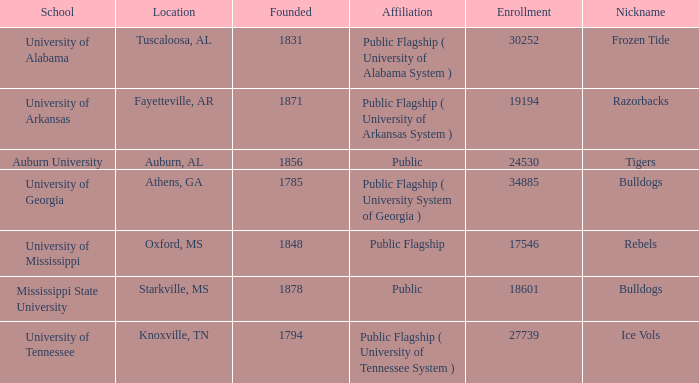What is the maximum enrollment of the schools? 34885.0. 